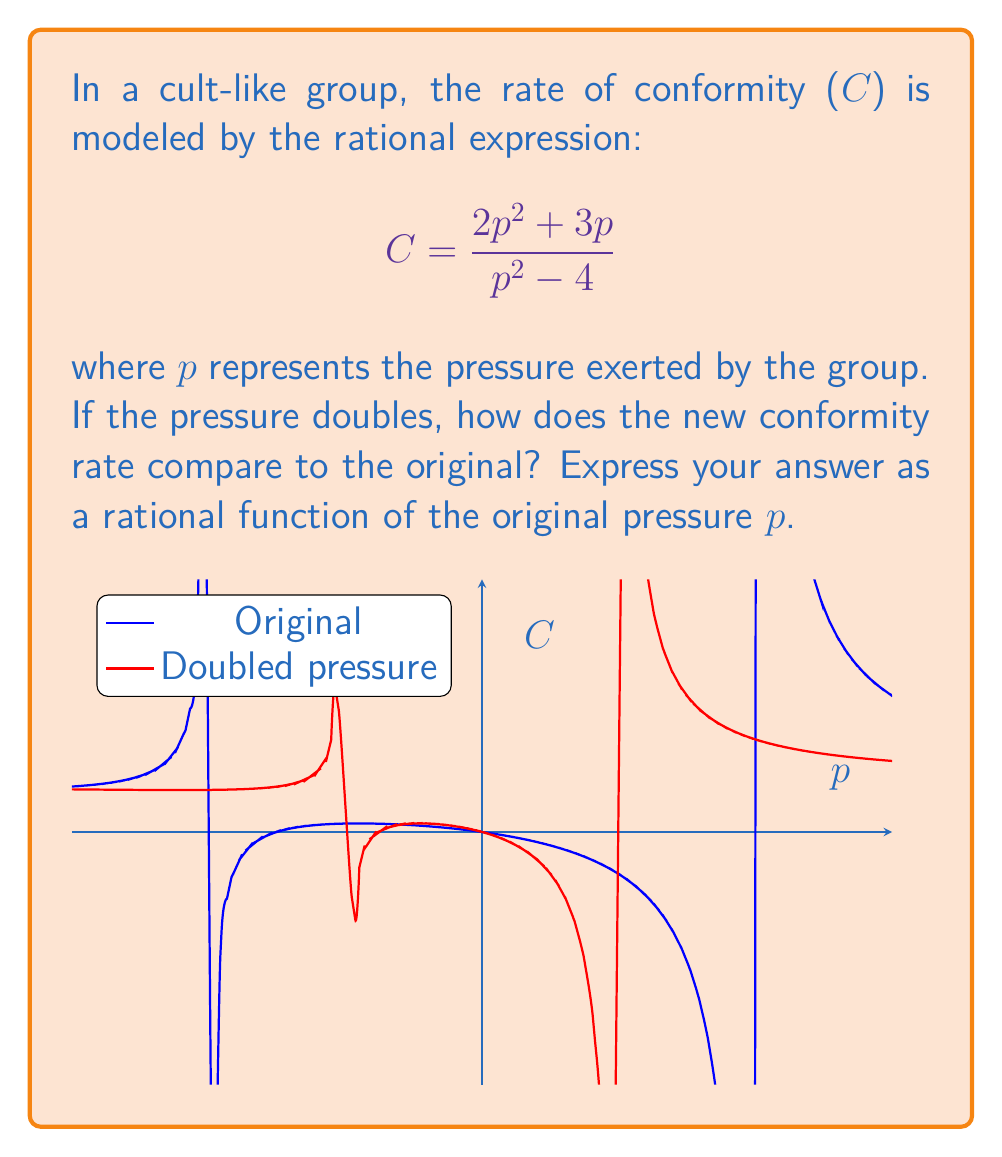Could you help me with this problem? Let's approach this step-by-step:

1) The original conformity rate is given by:
   $$C_1 = \frac{2p^2 + 3p}{p^2 - 4}$$

2) When the pressure doubles, p becomes 2p. Let's substitute this into the original equation:
   $$C_2 = \frac{2(2p)^2 + 3(2p)}{(2p)^2 - 4}$$

3) Simplify the numerator and denominator:
   $$C_2 = \frac{2(4p^2) + 6p}{4p^2 - 4} = \frac{8p^2 + 6p}{4p^2 - 4}$$

4) To compare the new rate to the original, we'll divide $C_2$ by $C_1$:
   $$\frac{C_2}{C_1} = \frac{\frac{8p^2 + 6p}{4p^2 - 4}}{\frac{2p^2 + 3p}{p^2 - 4}}$$

5) When dividing rational expressions, we multiply by the reciprocal:
   $$\frac{C_2}{C_1} = \frac{8p^2 + 6p}{4p^2 - 4} \cdot \frac{p^2 - 4}{2p^2 + 3p}$$

6) Cancel common factors in numerator and denominator:
   $$\frac{C_2}{C_1} = \frac{4p^2 + 3p}{2p^2 + 3p} = \frac{4p + 3}{2p + 3}$$

This final expression represents how the new conformity rate compares to the original as a function of the original pressure p.
Answer: $$\frac{4p + 3}{2p + 3}$$ 